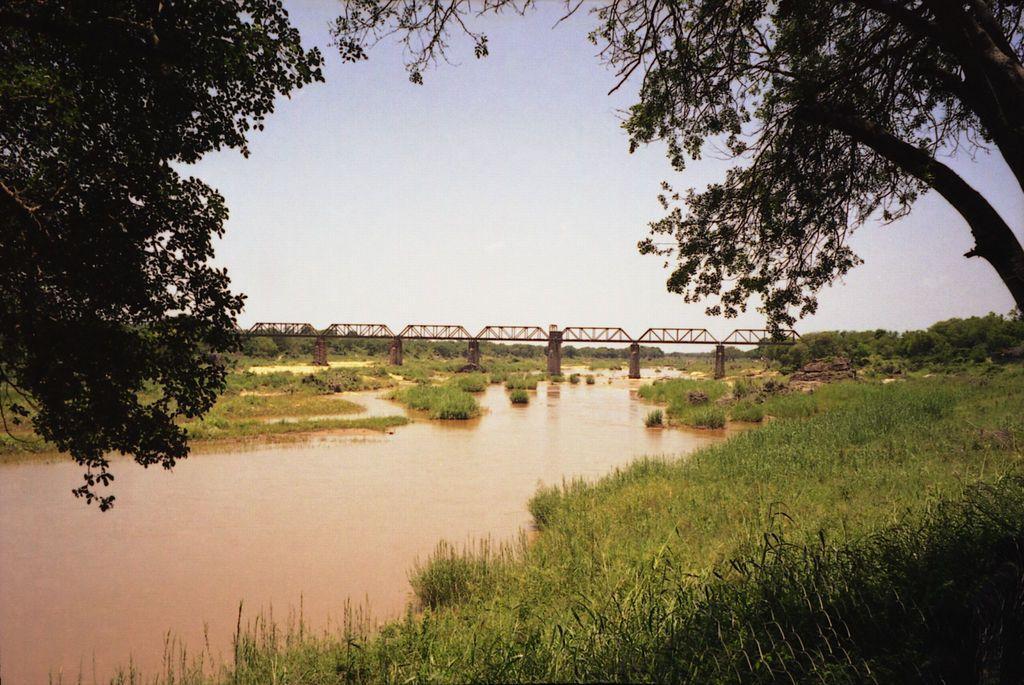In one or two sentences, can you explain what this image depicts? In this image we can see a bridge. There is a river in the image. There is a sky in the image. There are many trees and plants in the image. 